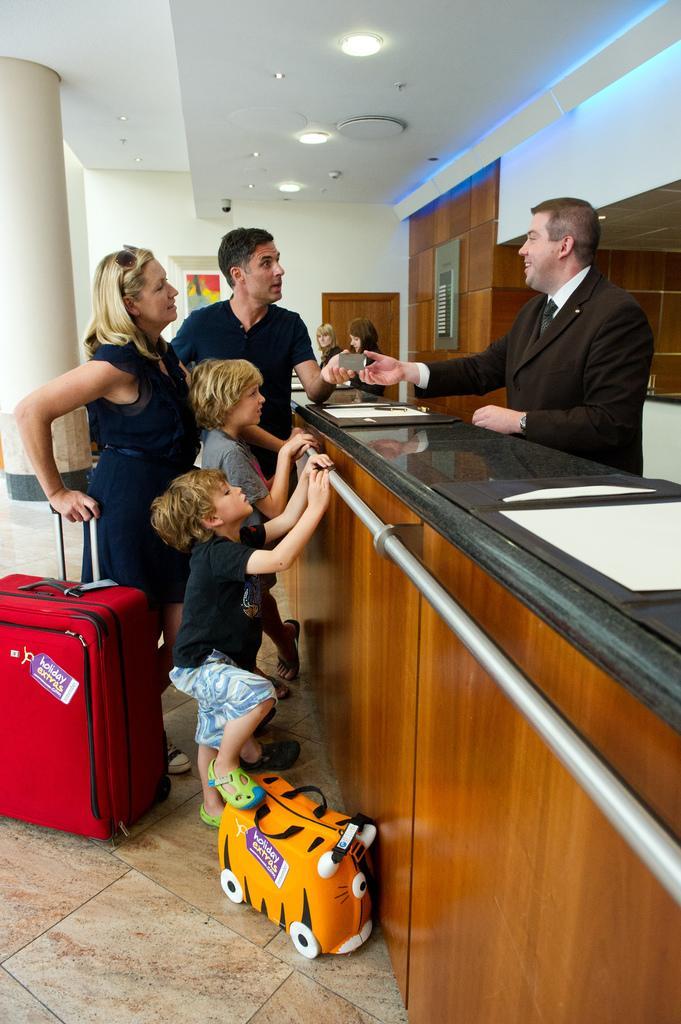How would you summarize this image in a sentence or two? In this picture there is a man who is wearing a suit. On the left there is a woman who is wearing black dress and goggles. She is holding a suitcase beside her we can see two boys were standing near to the table. On the table we can see the files and other object, beside the pillar there is a man who is wearing a black t-shirt. In the background there are two women were standing near to the door. At the top we can see the lights, camera and speaker. At the bottom there is a bag 